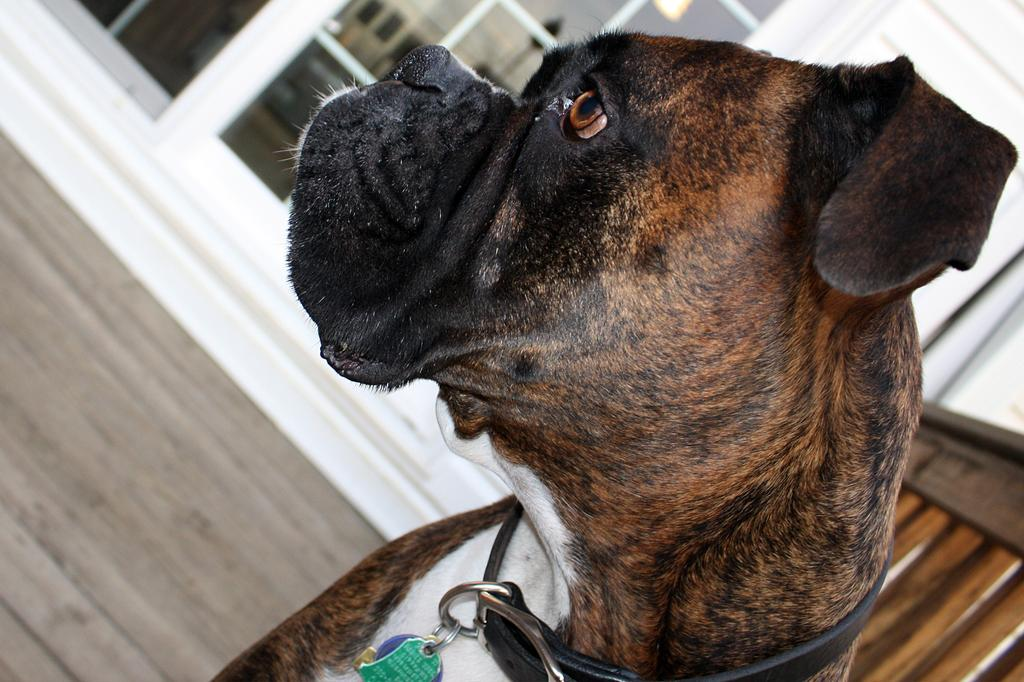What type of animal is in the image? There is a dog in the image. What colors can be seen on the dog? The dog has black, brown, and white colors. Is there any accessory or item worn by the dog? Yes, the dog is wearing a belt. What can be seen in the background of the image? There is a building in the background of the image. How many bottles of polish are needed to paint the dog in the image? There is no need for polish in the image, as the dog is not being painted. Additionally, the dog's colors are natural, not painted. 